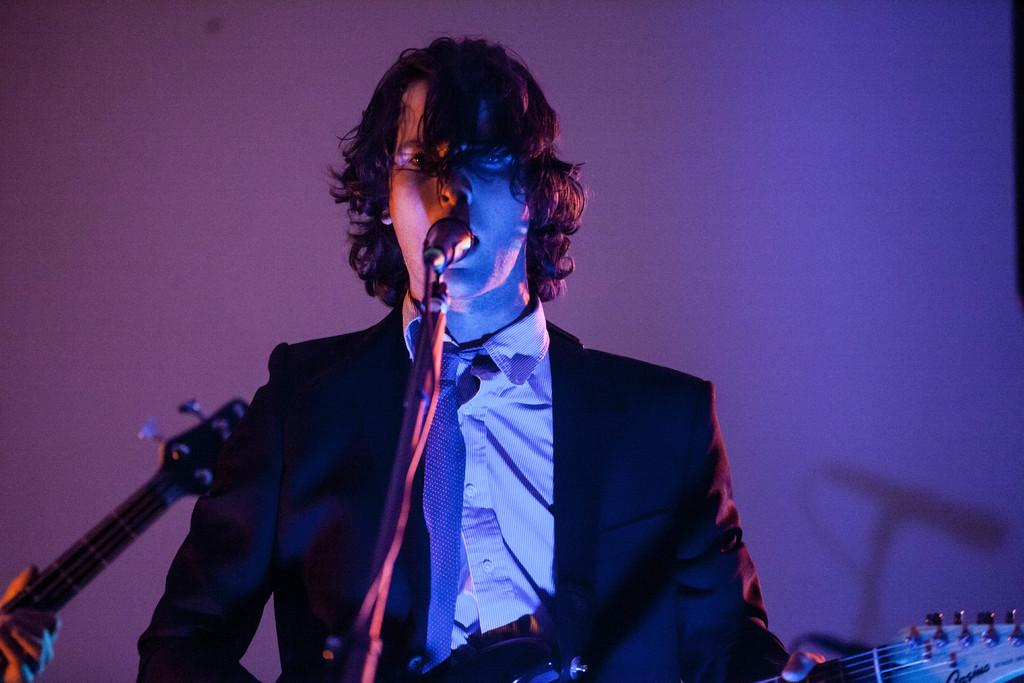What is the main activity being performed in the image? There is a person playing a guitar in the image. What is placed in front of the person playing the guitar? There is a microphone in front of the person playing the guitar. Can you describe the position of the second person in the image? There is a person's hand holding a guitar beside the person playing the guitar. What can be seen in the background of the image? There is a wall in the background of the image. What type of loaf is being used as a prop in the image? There is no loaf present in the image; it features a person playing a guitar and a person holding a guitar. Can you see any sails in the image? There are no sails present in the image; it is focused on people playing guitars and a microphone. 